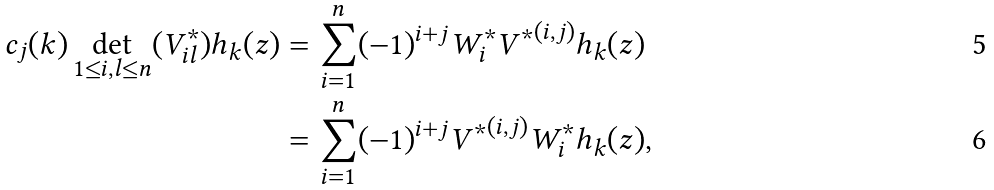<formula> <loc_0><loc_0><loc_500><loc_500>c _ { j } ( k ) \det _ { 1 \leq i , l \leq n } ( V _ { i l } ^ { * } ) h _ { k } ( z ) & = \sum _ { i = 1 } ^ { n } ( - 1 ) ^ { i + j } W _ { i } ^ { * } { V ^ { * } } ^ { ( i , j ) } h _ { k } ( z ) \\ & = \sum _ { i = 1 } ^ { n } ( - 1 ) ^ { i + j } { V ^ { * } } ^ { ( i , j ) } W _ { i } ^ { * } h _ { k } ( z ) ,</formula> 